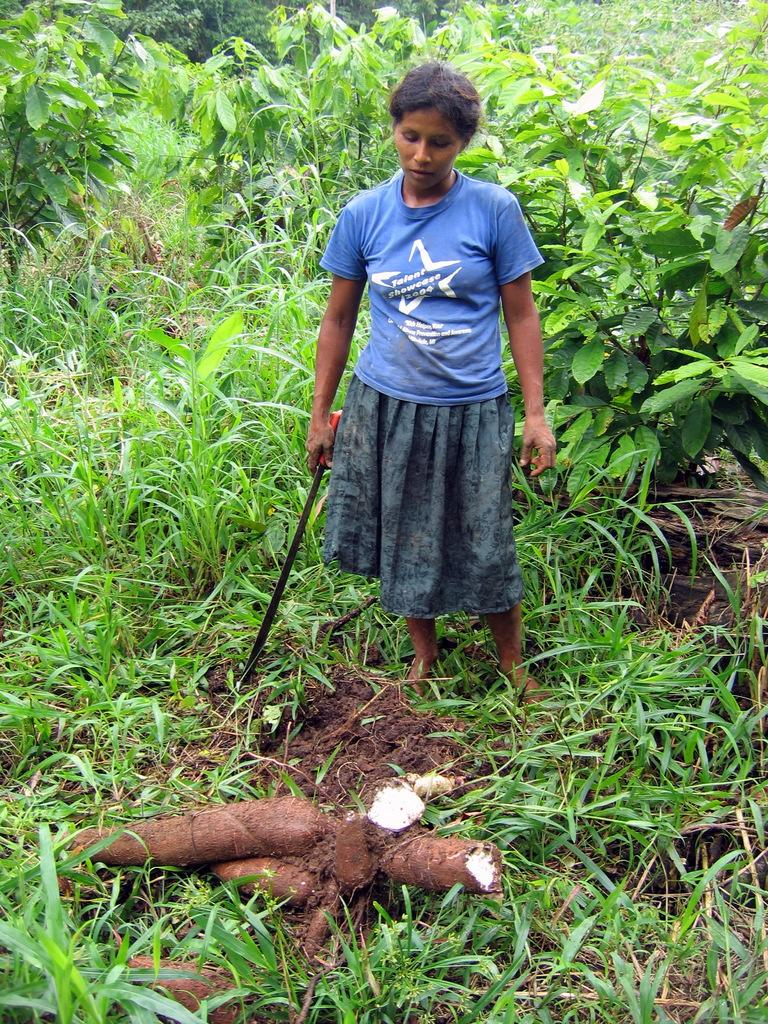What type of living organisms can be seen in the image? Plants can be seen in the image. Who is present in the image? There is a woman in the image. What is the woman holding in the image? The woman is holding a digging instrument. What type of ground surface is visible in the image? There is grass on the ground in the image. What type of vegetable is being harvested by the fairies in the image? There are no fairies present in the image, and therefore no vegetable harvesting can be observed. 